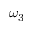Convert formula to latex. <formula><loc_0><loc_0><loc_500><loc_500>\omega _ { 3 }</formula> 